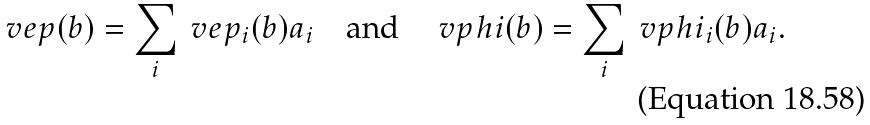<formula> <loc_0><loc_0><loc_500><loc_500>\ v e p ( b ) = \sum _ { i } \ v e p _ { i } ( b ) \L a _ { i } \quad \text {and} \quad \ v p h i ( b ) = \sum _ { i } \ v p h i _ { i } ( b ) \L a _ { i } .</formula> 